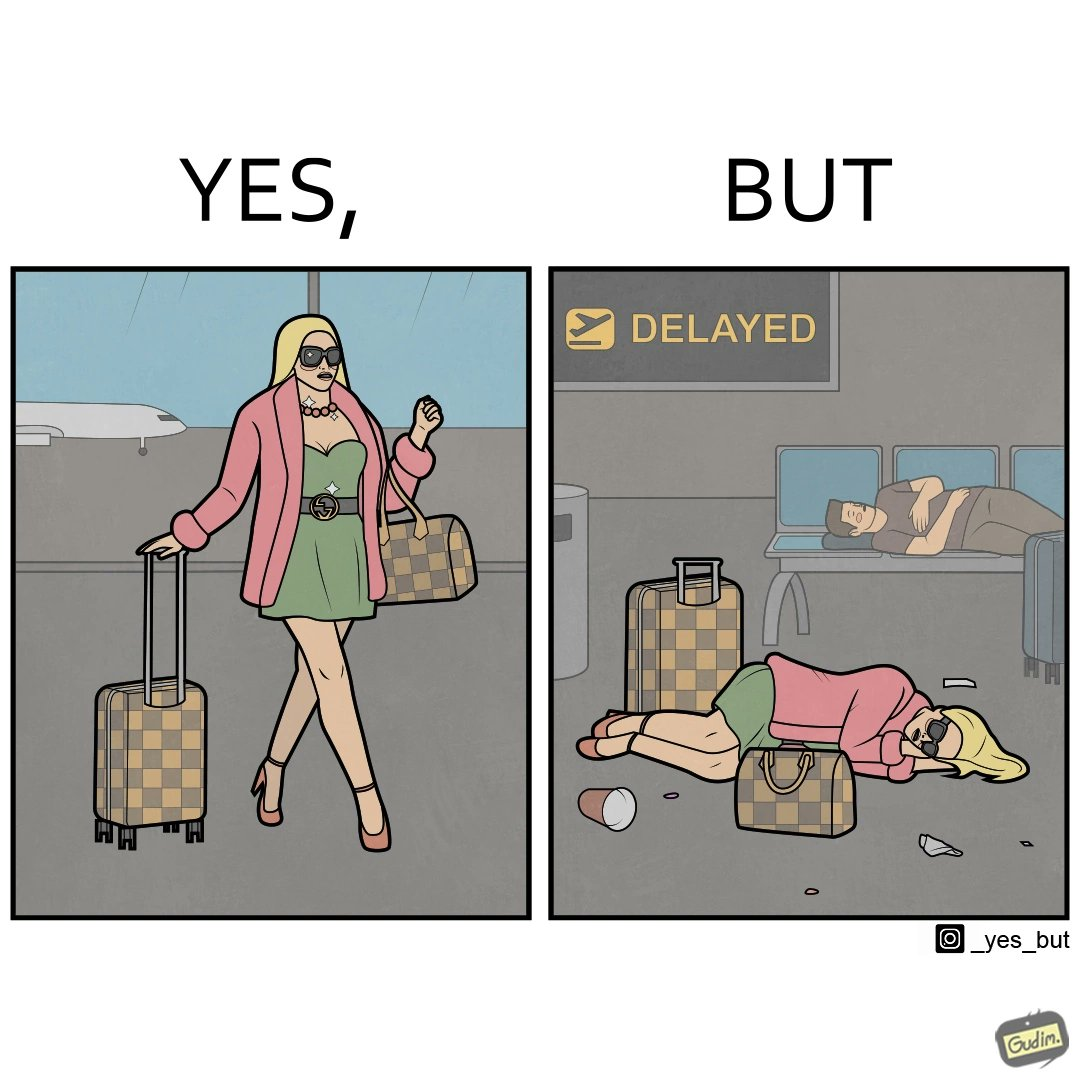Explain why this image is satirical. The image is ironical, as an apparently rich person walks inside the airport with luggage, but has to sleep on the floor  due to the flight being delayed and an absence of vacant seats in the airport. 